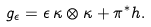Convert formula to latex. <formula><loc_0><loc_0><loc_500><loc_500>g _ { \epsilon } = \epsilon \, \kappa \otimes \kappa + \pi ^ { * } h .</formula> 